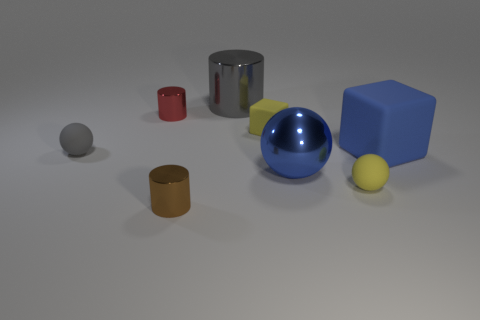Subtract all small metal cylinders. How many cylinders are left? 1 Subtract all yellow spheres. How many spheres are left? 2 Add 1 blue shiny balls. How many objects exist? 9 Subtract 2 blocks. How many blocks are left? 0 Subtract 0 red spheres. How many objects are left? 8 Subtract all balls. How many objects are left? 5 Subtract all gray cylinders. Subtract all purple cubes. How many cylinders are left? 2 Subtract all purple balls. How many yellow blocks are left? 1 Subtract all large objects. Subtract all rubber balls. How many objects are left? 3 Add 4 tiny yellow matte balls. How many tiny yellow matte balls are left? 5 